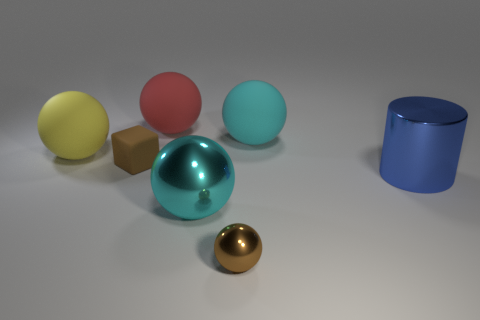Add 3 small green cubes. How many objects exist? 10 Subtract all big metal balls. How many balls are left? 4 Subtract 1 cylinders. How many cylinders are left? 0 Subtract 0 yellow blocks. How many objects are left? 7 Subtract all balls. How many objects are left? 2 Subtract all blue blocks. Subtract all cyan cylinders. How many blocks are left? 1 Subtract all brown blocks. How many yellow balls are left? 1 Subtract all tiny purple shiny spheres. Subtract all small rubber cubes. How many objects are left? 6 Add 1 cyan metallic things. How many cyan metallic things are left? 2 Add 1 cyan balls. How many cyan balls exist? 3 